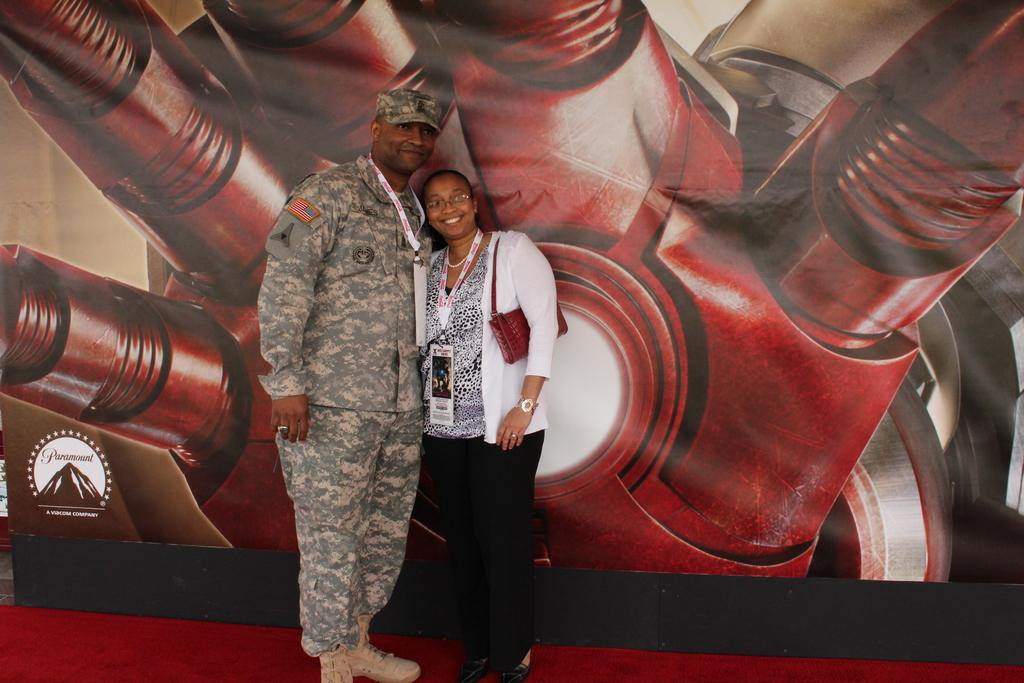What can be seen in the image? There are people standing in the image. What are the people wearing around their necks? The people are wearing ID cards around their necks. What else is visible in the image? There is a banner visible in the image. What type of house can be seen in the background of the image? There is no house visible in the image; it only shows people standing and a banner. What is the value of the food being cooked in the image? There is no food or cooking activity present in the image. 